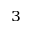<formula> <loc_0><loc_0><loc_500><loc_500>_ { 3 }</formula> 